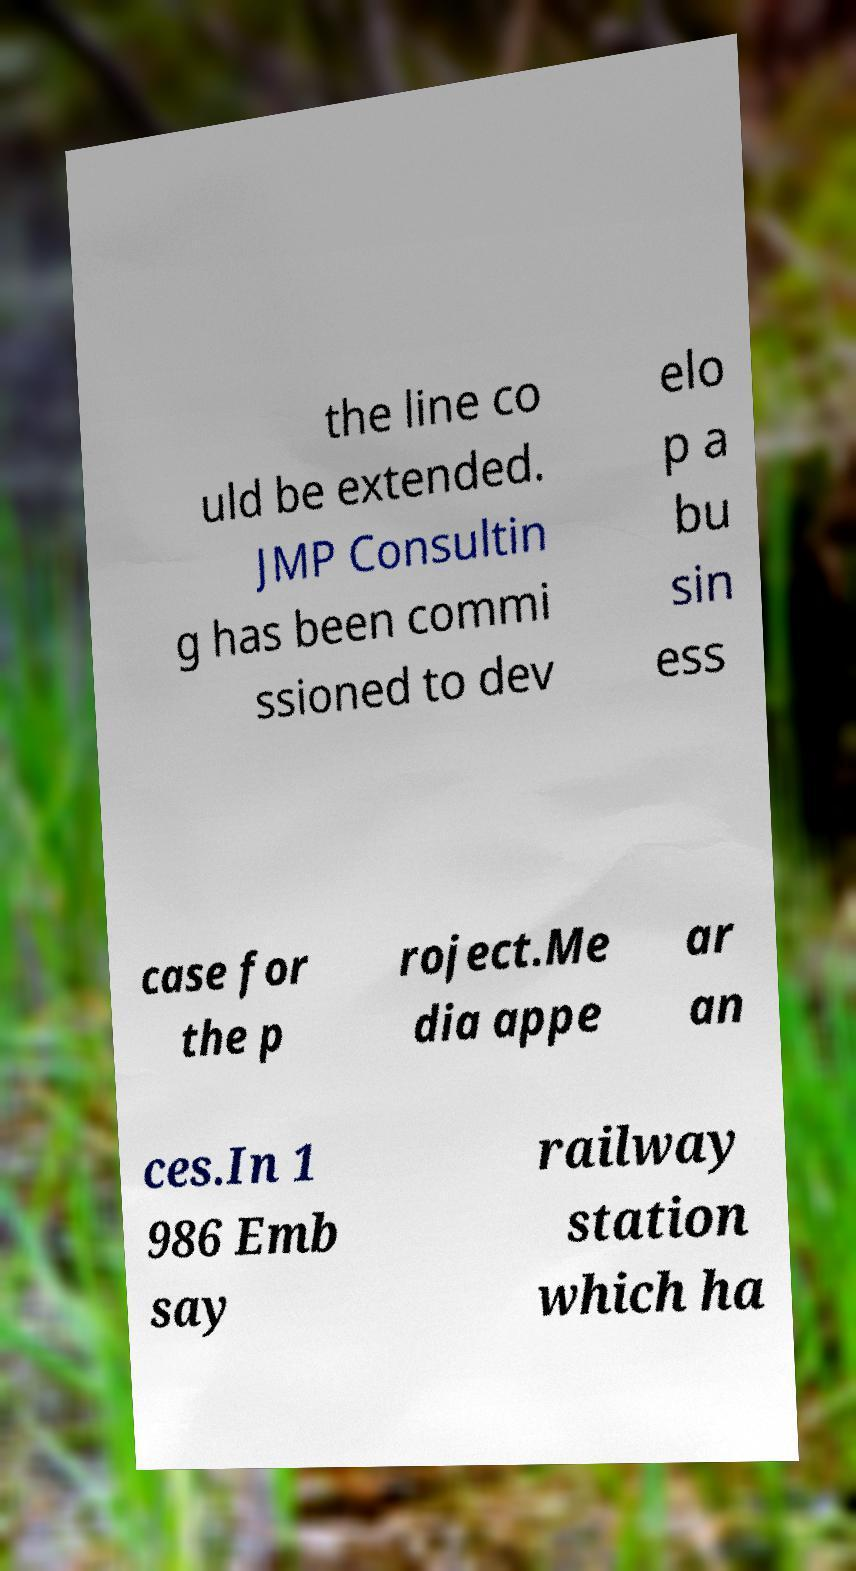I need the written content from this picture converted into text. Can you do that? the line co uld be extended. JMP Consultin g has been commi ssioned to dev elo p a bu sin ess case for the p roject.Me dia appe ar an ces.In 1 986 Emb say railway station which ha 